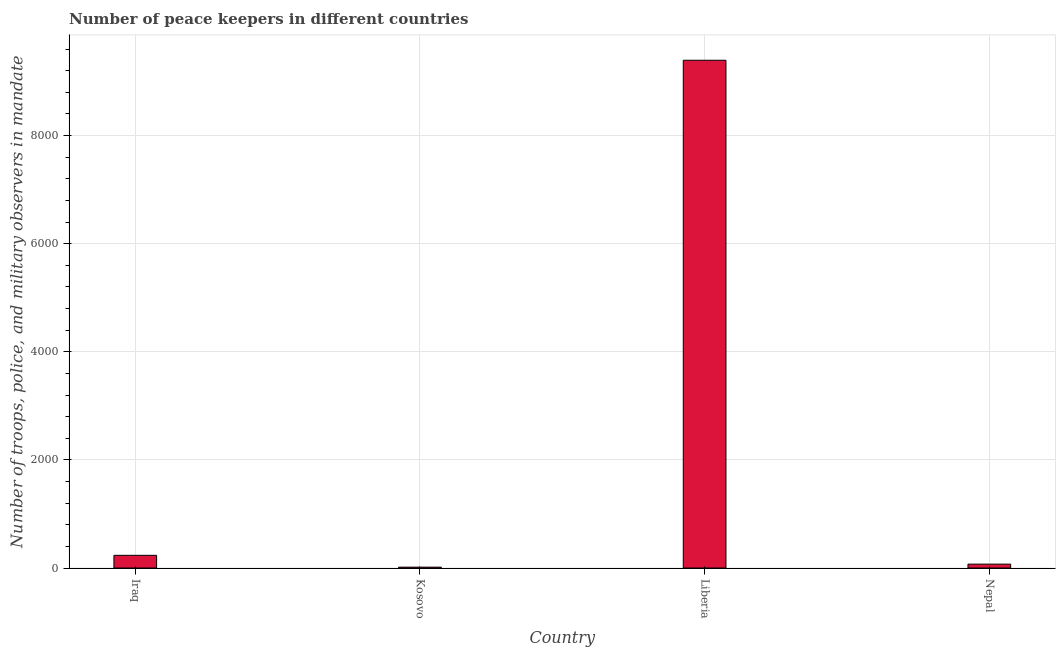Does the graph contain any zero values?
Ensure brevity in your answer.  No. What is the title of the graph?
Provide a succinct answer. Number of peace keepers in different countries. What is the label or title of the X-axis?
Make the answer very short. Country. What is the label or title of the Y-axis?
Provide a short and direct response. Number of troops, police, and military observers in mandate. What is the number of peace keepers in Kosovo?
Provide a short and direct response. 16. Across all countries, what is the maximum number of peace keepers?
Ensure brevity in your answer.  9392. In which country was the number of peace keepers maximum?
Make the answer very short. Liberia. In which country was the number of peace keepers minimum?
Your response must be concise. Kosovo. What is the sum of the number of peace keepers?
Provide a short and direct response. 9715. What is the difference between the number of peace keepers in Kosovo and Nepal?
Ensure brevity in your answer.  -56. What is the average number of peace keepers per country?
Offer a very short reply. 2428. What is the median number of peace keepers?
Make the answer very short. 153.5. In how many countries, is the number of peace keepers greater than 4000 ?
Keep it short and to the point. 1. What is the ratio of the number of peace keepers in Liberia to that in Nepal?
Your answer should be compact. 130.44. What is the difference between the highest and the second highest number of peace keepers?
Your response must be concise. 9157. What is the difference between the highest and the lowest number of peace keepers?
Your answer should be very brief. 9376. In how many countries, is the number of peace keepers greater than the average number of peace keepers taken over all countries?
Give a very brief answer. 1. How many bars are there?
Keep it short and to the point. 4. What is the difference between two consecutive major ticks on the Y-axis?
Give a very brief answer. 2000. What is the Number of troops, police, and military observers in mandate of Iraq?
Provide a short and direct response. 235. What is the Number of troops, police, and military observers in mandate of Liberia?
Keep it short and to the point. 9392. What is the Number of troops, police, and military observers in mandate of Nepal?
Your answer should be very brief. 72. What is the difference between the Number of troops, police, and military observers in mandate in Iraq and Kosovo?
Give a very brief answer. 219. What is the difference between the Number of troops, police, and military observers in mandate in Iraq and Liberia?
Provide a succinct answer. -9157. What is the difference between the Number of troops, police, and military observers in mandate in Iraq and Nepal?
Offer a terse response. 163. What is the difference between the Number of troops, police, and military observers in mandate in Kosovo and Liberia?
Provide a succinct answer. -9376. What is the difference between the Number of troops, police, and military observers in mandate in Kosovo and Nepal?
Provide a short and direct response. -56. What is the difference between the Number of troops, police, and military observers in mandate in Liberia and Nepal?
Ensure brevity in your answer.  9320. What is the ratio of the Number of troops, police, and military observers in mandate in Iraq to that in Kosovo?
Provide a short and direct response. 14.69. What is the ratio of the Number of troops, police, and military observers in mandate in Iraq to that in Liberia?
Provide a succinct answer. 0.03. What is the ratio of the Number of troops, police, and military observers in mandate in Iraq to that in Nepal?
Give a very brief answer. 3.26. What is the ratio of the Number of troops, police, and military observers in mandate in Kosovo to that in Liberia?
Give a very brief answer. 0. What is the ratio of the Number of troops, police, and military observers in mandate in Kosovo to that in Nepal?
Keep it short and to the point. 0.22. What is the ratio of the Number of troops, police, and military observers in mandate in Liberia to that in Nepal?
Make the answer very short. 130.44. 